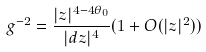<formula> <loc_0><loc_0><loc_500><loc_500>g ^ { - 2 } = \frac { | z | ^ { 4 - 4 \theta _ { 0 } } } { | d z | ^ { 4 } } { ( 1 + O ( | z | ^ { 2 } ) ) }</formula> 